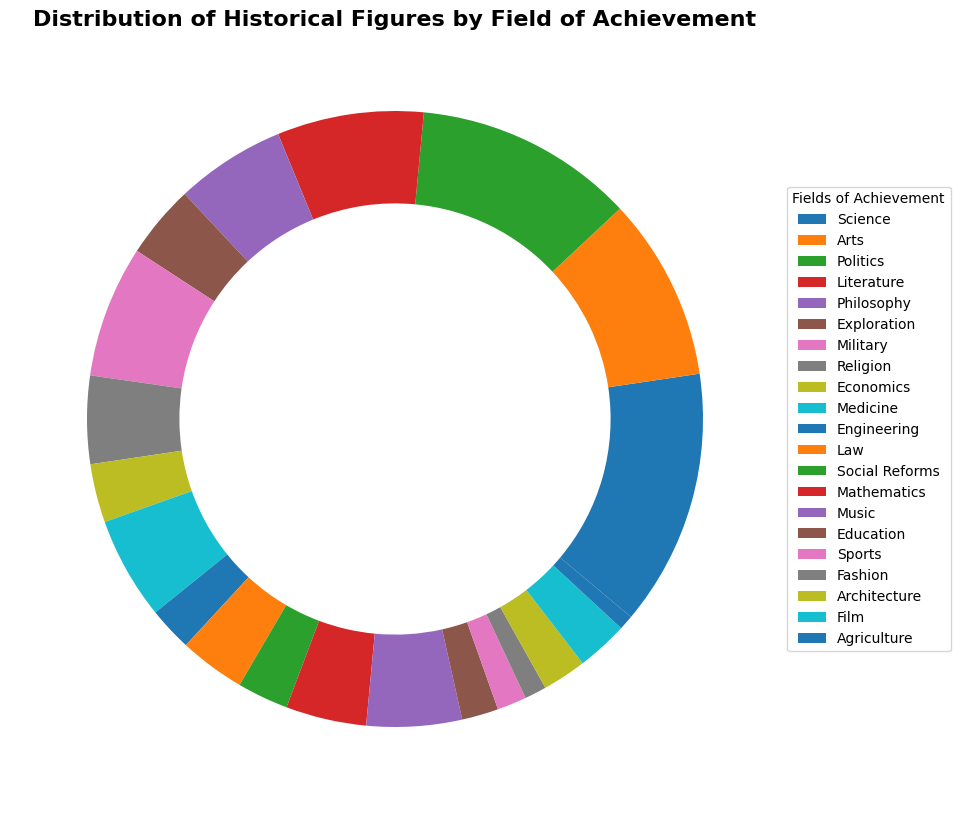Which field has the largest number of historical figures? The figure segments representing different fields show varying sizes. The segment for "Science" appears the largest, suggesting it has the greatest number of historical figures.
Answer: Science Which field has fewer historical figures, Medicine or Military? By comparing the sizes of the segments for "Medicine" and "Military," the segment for "Medicine" is slightly smaller, indicating it has fewer historical figures.
Answer: Medicine What is the total number of historical figures in the fields of Mathematics and Music combined? The figure shows individual numbers for each field. Mathematics has 11 and Music has 13 historical figures. Summing them: 11 + 13 = 24.
Answer: 24 Are there more historical figures in Politics or Arts? Comparing the segment sizes for "Politics" and "Arts," the "Politics" segment is larger, indicating there are more figures in Politics.
Answer: Politics Which field has the smallest number of historical figures? The smallest segment in the ring chart represents "Agriculture," indicating it has the least number of historical figures.
Answer: Agriculture By how many do figures in Exploration exceed those in Law? The Exploration segment includes 10 figures, and Law has 9 figures. The difference is: 10 - 9 = 1.
Answer: 1 Which has more historical figures: Philosophy and Social Reforms combined, or Education and Sports combined? First, sum the figures in Philosophy (15) and Social Reforms (7): 15 + 7 = 22. Then sum the figures in Education (5) and Sports (4): 5 + 4 = 9. Comparing 22 to 9, Philosophy and Social Reforms combined have more historical figures.
Answer: Philosophy and Social Reforms combined What is the median number of historical figures across all fields? Arrange the number of historical figures per field in ascending order: 2, 3, 4, 5, 6, 6, 7, 7, 8, 9, 10, 11, 12, 13, 14, 15, 18, 20, 25, 30, 35. The median is the middle value, so here it's the 11th value: 10.
Answer: 10 